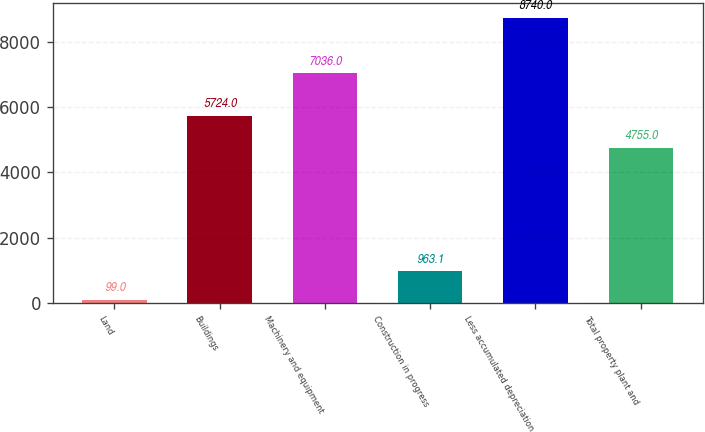<chart> <loc_0><loc_0><loc_500><loc_500><bar_chart><fcel>Land<fcel>Buildings<fcel>Machinery and equipment<fcel>Construction in progress<fcel>Less accumulated depreciation<fcel>Total property plant and<nl><fcel>99<fcel>5724<fcel>7036<fcel>963.1<fcel>8740<fcel>4755<nl></chart> 